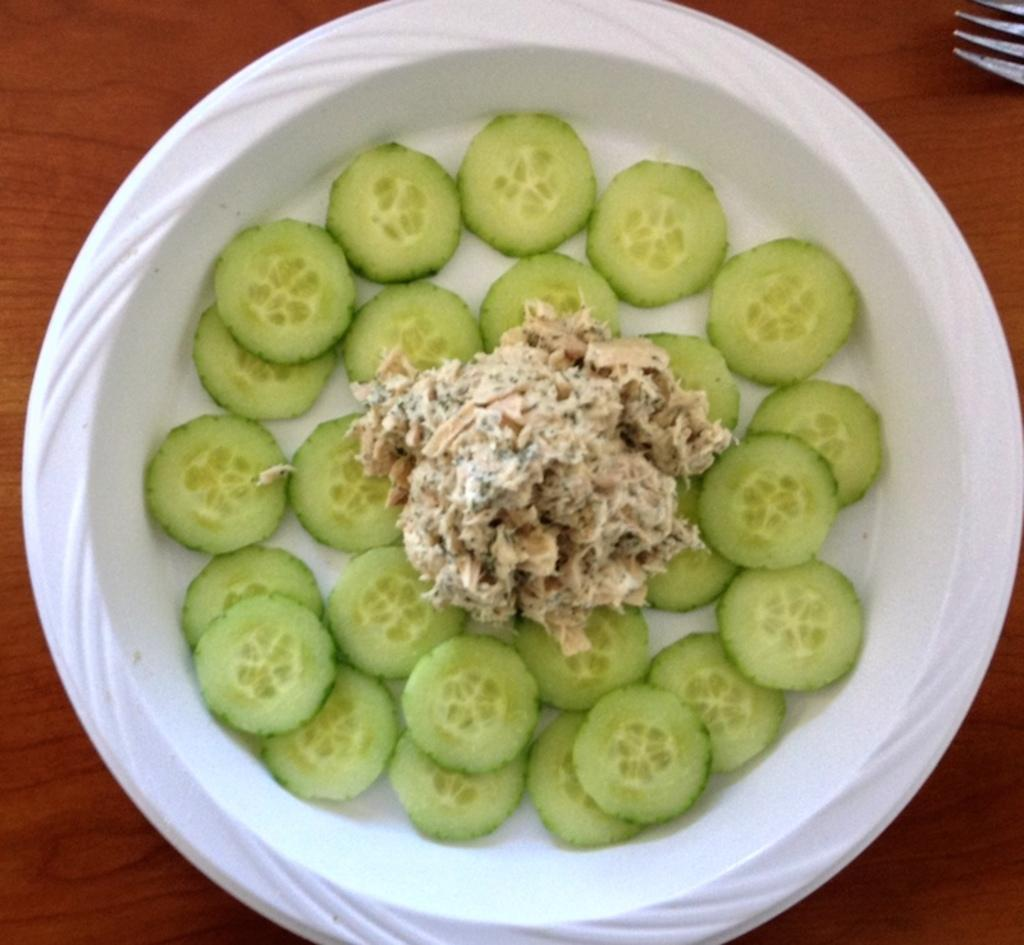What is in the bowl that is visible in the image? There is food in a bowl in the image. Where is the bowl located in the image? The bowl is on a wooden surface. What utensil can be seen in the image? There is a fork in the top right corner of the image. How many baskets are visible in the image? There are no baskets present in the image. What is the level of friction between the bowl and the wooden surface? The level of friction between the bowl and the wooden surface cannot be determined from the image. 